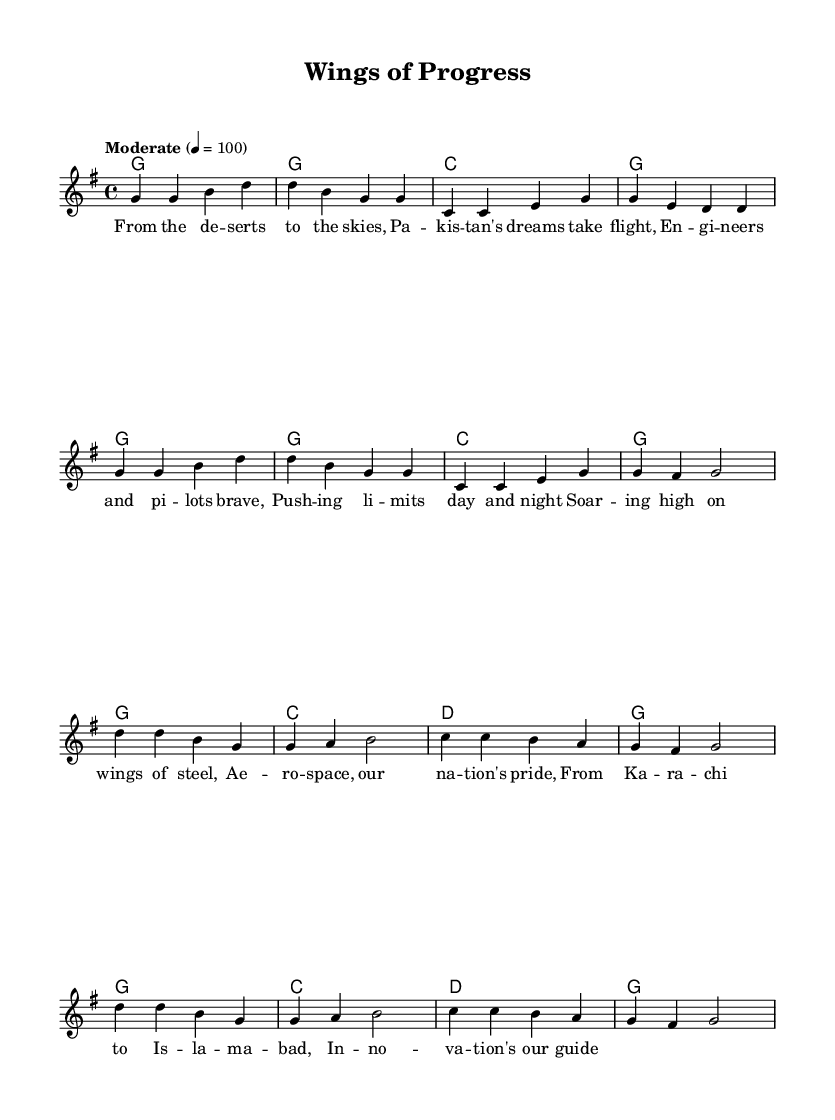What is the key signature of this music? The key signature is G major, which has one sharp (F#). This can be identified by looking at the key signature indicated at the beginning of the staff, which shows the position of F# on the staff.
Answer: G major What is the time signature of this music? The time signature is 4/4, which means there are four beats in each measure and the quarter note gets one beat. This is indicated at the start of the music sheet where the time signature is placed.
Answer: 4/4 What is the tempo marking of this music? The tempo marking is "Moderate," with a metronome marking of 100 beats per minute. This is indicated near the beginning of the score where tempo instructions are typically located.
Answer: Moderate, 100 How many measures are in the verse section? There are 8 measures in the verse section. By counting the vertical bar lines in the melody part that correspond to the verse lyrics, we see there are 8 distinct measures.
Answer: 8 What is the structure of the chorus? The chorus consists of 8 measures, similar to the verse in terms of length. To determine this, we can look at the melody and harmonies written for the chorus and count the measures based on the bar lines.
Answer: 8 measures What is the main theme of the lyrics? The main theme of the lyrics is about national pride in aerospace engineering and innovation. We can deduce this by analyzing the content of the lyrics, which speaks to themes of flying and pushing limits in the context of Pakistan.
Answer: National pride in aerospace In what context does this anthem celebrate aerospace engineering? This anthem celebrates aerospace engineering by emphasizing the contributions of engineers and pilots in achieving national aspirations. This is clear through the lyrics which highlight dreams, innovation, and the pride associated with aerospace achievements across the country.
Answer: Celebration of national aerospace achievements 